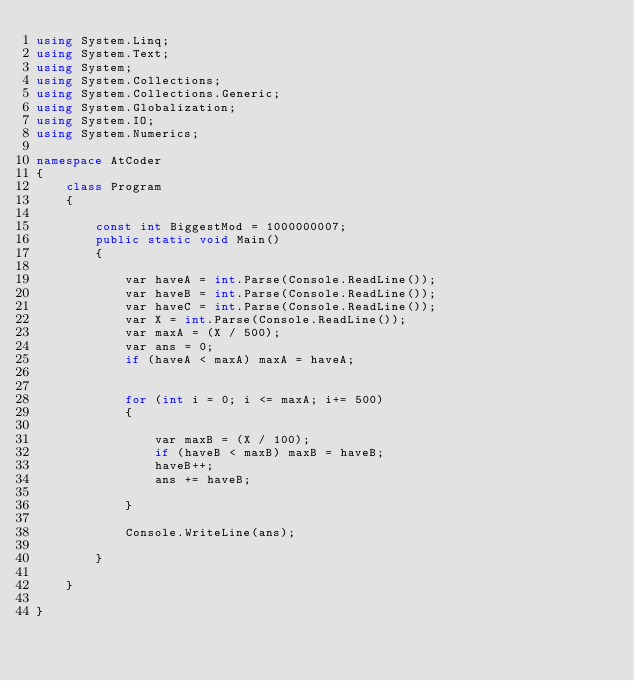<code> <loc_0><loc_0><loc_500><loc_500><_C#_>using System.Linq;
using System.Text;
using System;
using System.Collections;
using System.Collections.Generic;
using System.Globalization;
using System.IO;
using System.Numerics;

namespace AtCoder
{
    class Program
    {

        const int BiggestMod = 1000000007;
        public static void Main()
        {

            var haveA = int.Parse(Console.ReadLine());
            var haveB = int.Parse(Console.ReadLine());
            var haveC = int.Parse(Console.ReadLine());
            var X = int.Parse(Console.ReadLine());
            var maxA = (X / 500);
            var ans = 0;
            if (haveA < maxA) maxA = haveA;


            for (int i = 0; i <= maxA; i+= 500)
            {

                var maxB = (X / 100);
                if (haveB < maxB) maxB = haveB;
                haveB++;
                ans += haveB;

            }

            Console.WriteLine(ans);

        }

    }

}
</code> 